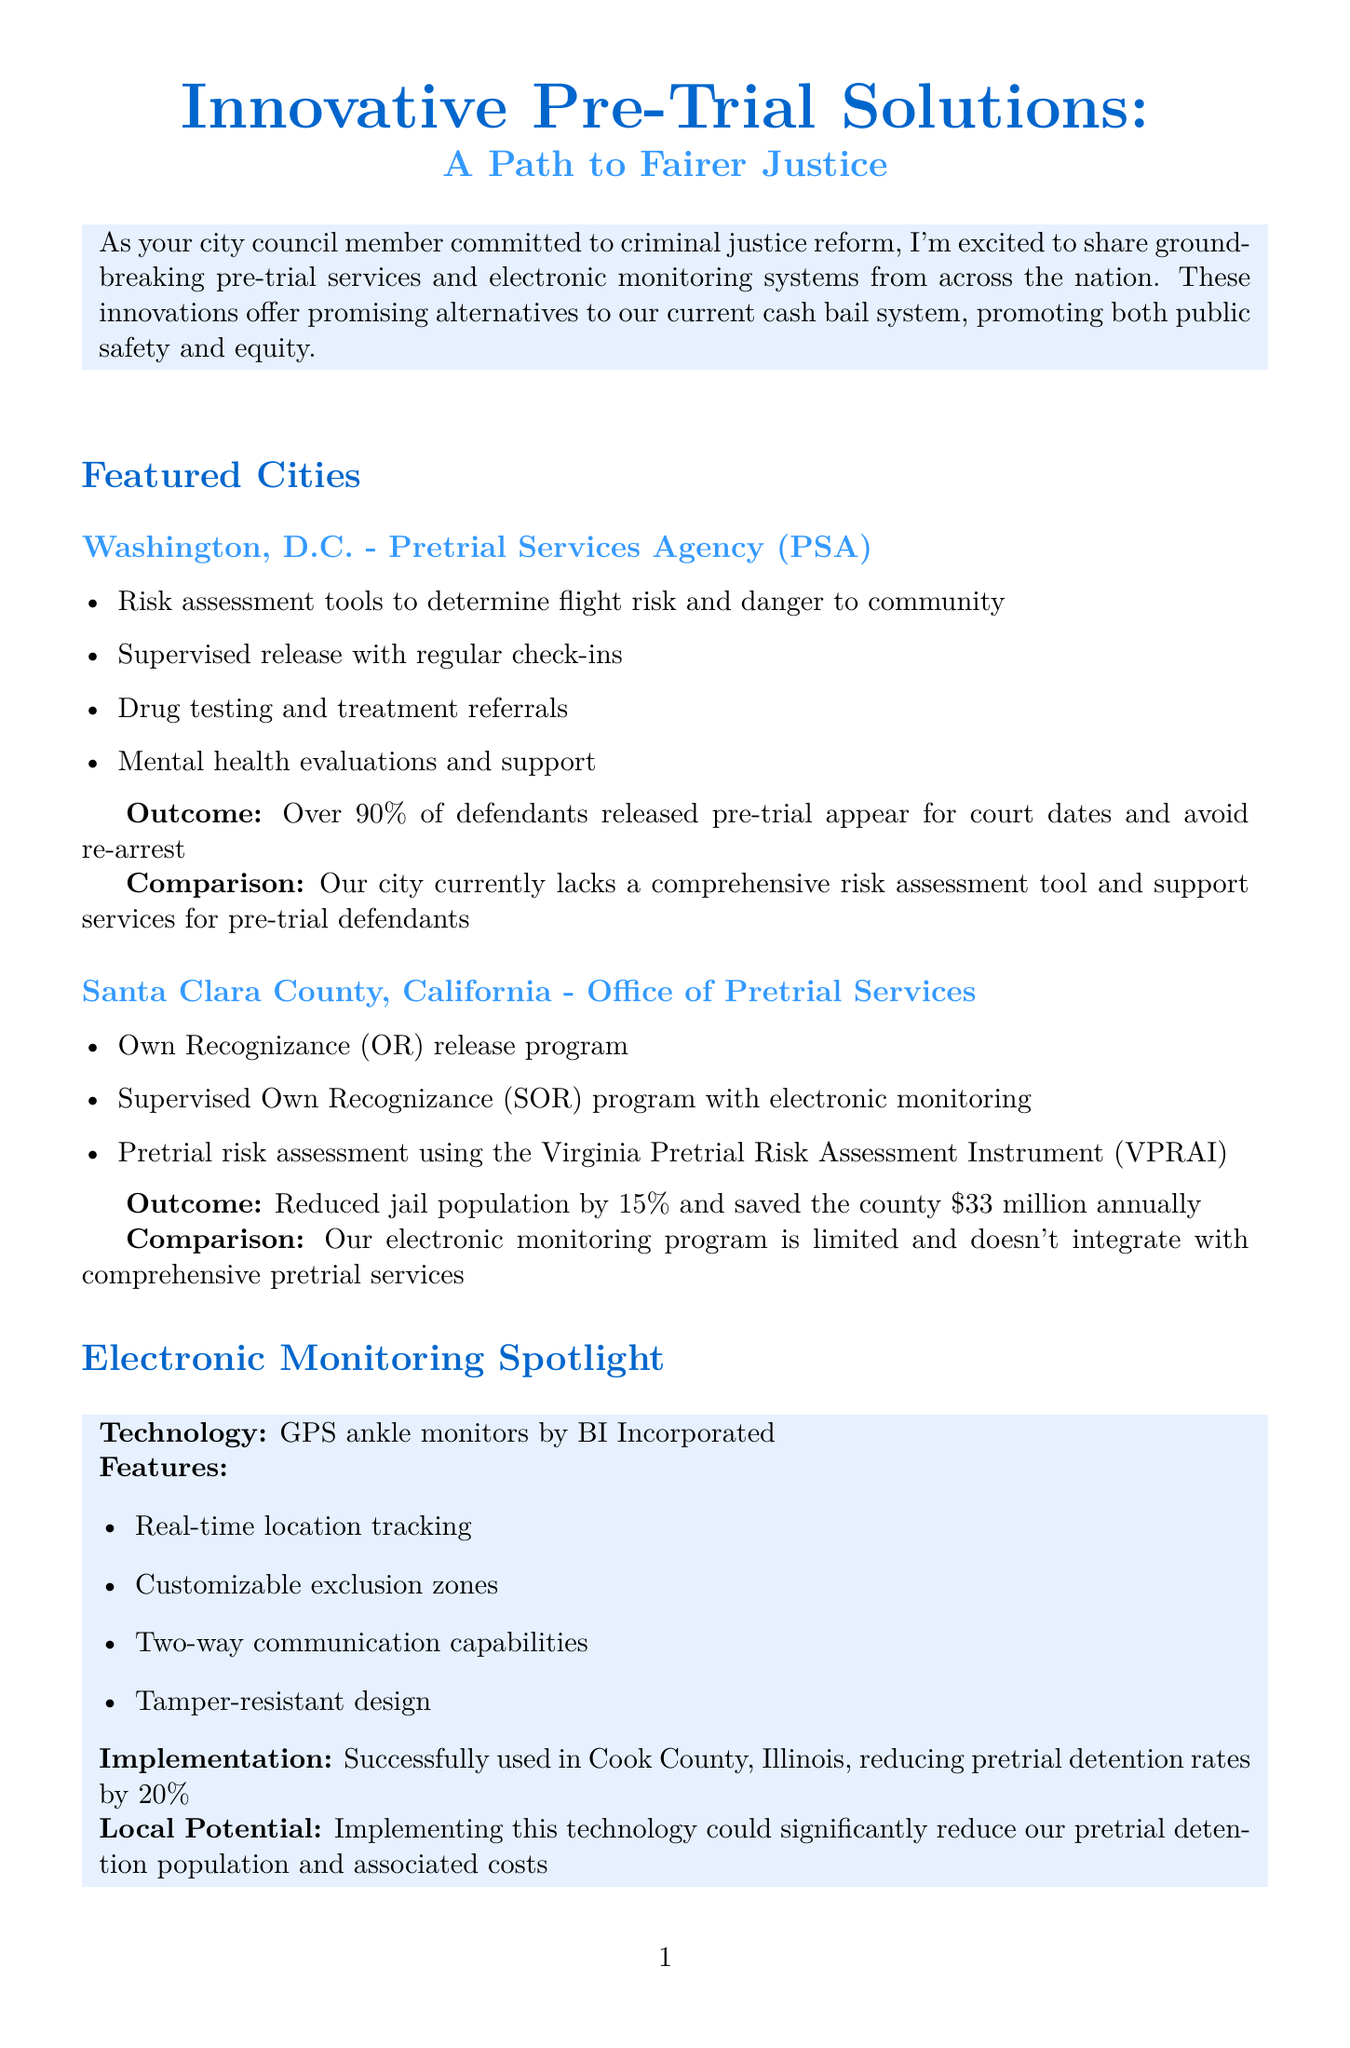What is the title of the newsletter? The title of the newsletter is indicated at the beginning of the document.
Answer: Innovative Pre-Trial Solutions: A Path to Fairer Justice What percentage of defendants in Washington, D.C. appear for court dates? This information is explicitly mentioned as part of the outcomes for Washington, D.C. in the newsletter.
Answer: Over 90% What program is implemented in Santa Clara County, California? The program name is highlighted in the section for Santa Clara County in the document.
Answer: Office of Pretrial Services What technology is spotlighted for electronic monitoring? The document specifies the technology used in electronic monitoring systems.
Answer: GPS ankle monitors by BI Incorporated What is the estimated annual cost for comprehensive pretrial services and electronic monitoring? This cost is provided in the cost-benefit analysis section of the document.
Answer: $5 million How much did Santa Clara County save annually after implementing pretrial services? The document mentions the savings as part of the outcomes for Santa Clara County.
Answer: $33 million What is a proposed next step in the document? A next step is mentioned in the last section of the newsletter.
Answer: Form a task force to study successful pre-trial service models What is the date of the upcoming town hall? The date is mentioned in the call to action section of the document.
Answer: May 15th 